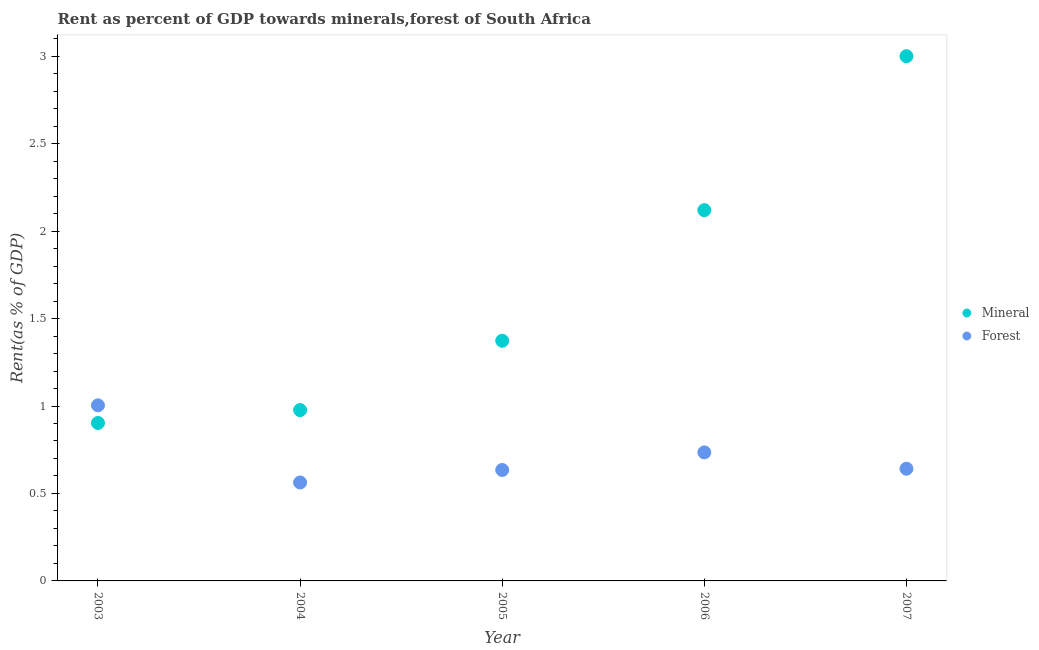What is the forest rent in 2005?
Provide a succinct answer. 0.63. Across all years, what is the maximum mineral rent?
Keep it short and to the point. 3. Across all years, what is the minimum forest rent?
Ensure brevity in your answer.  0.56. What is the total mineral rent in the graph?
Your response must be concise. 8.37. What is the difference between the mineral rent in 2004 and that in 2005?
Offer a terse response. -0.4. What is the difference between the mineral rent in 2003 and the forest rent in 2007?
Give a very brief answer. 0.26. What is the average forest rent per year?
Ensure brevity in your answer.  0.72. In the year 2003, what is the difference between the mineral rent and forest rent?
Provide a succinct answer. -0.1. What is the ratio of the mineral rent in 2005 to that in 2006?
Your answer should be very brief. 0.65. Is the forest rent in 2004 less than that in 2006?
Keep it short and to the point. Yes. What is the difference between the highest and the second highest forest rent?
Your answer should be very brief. 0.27. What is the difference between the highest and the lowest mineral rent?
Your answer should be very brief. 2.1. Is the sum of the forest rent in 2003 and 2007 greater than the maximum mineral rent across all years?
Provide a succinct answer. No. How many dotlines are there?
Give a very brief answer. 2. What is the difference between two consecutive major ticks on the Y-axis?
Keep it short and to the point. 0.5. Does the graph contain grids?
Your response must be concise. No. Where does the legend appear in the graph?
Make the answer very short. Center right. How are the legend labels stacked?
Provide a short and direct response. Vertical. What is the title of the graph?
Make the answer very short. Rent as percent of GDP towards minerals,forest of South Africa. Does "From human activities" appear as one of the legend labels in the graph?
Your answer should be compact. No. What is the label or title of the Y-axis?
Your answer should be very brief. Rent(as % of GDP). What is the Rent(as % of GDP) in Mineral in 2003?
Give a very brief answer. 0.9. What is the Rent(as % of GDP) in Forest in 2003?
Your answer should be very brief. 1. What is the Rent(as % of GDP) of Mineral in 2004?
Make the answer very short. 0.98. What is the Rent(as % of GDP) in Forest in 2004?
Your response must be concise. 0.56. What is the Rent(as % of GDP) in Mineral in 2005?
Provide a succinct answer. 1.37. What is the Rent(as % of GDP) of Forest in 2005?
Provide a succinct answer. 0.63. What is the Rent(as % of GDP) of Mineral in 2006?
Provide a succinct answer. 2.12. What is the Rent(as % of GDP) of Forest in 2006?
Make the answer very short. 0.73. What is the Rent(as % of GDP) in Mineral in 2007?
Provide a short and direct response. 3. What is the Rent(as % of GDP) in Forest in 2007?
Make the answer very short. 0.64. Across all years, what is the maximum Rent(as % of GDP) of Mineral?
Offer a terse response. 3. Across all years, what is the maximum Rent(as % of GDP) in Forest?
Offer a very short reply. 1. Across all years, what is the minimum Rent(as % of GDP) in Mineral?
Your answer should be very brief. 0.9. Across all years, what is the minimum Rent(as % of GDP) of Forest?
Your answer should be compact. 0.56. What is the total Rent(as % of GDP) in Mineral in the graph?
Ensure brevity in your answer.  8.37. What is the total Rent(as % of GDP) in Forest in the graph?
Give a very brief answer. 3.58. What is the difference between the Rent(as % of GDP) in Mineral in 2003 and that in 2004?
Offer a terse response. -0.07. What is the difference between the Rent(as % of GDP) in Forest in 2003 and that in 2004?
Provide a succinct answer. 0.44. What is the difference between the Rent(as % of GDP) of Mineral in 2003 and that in 2005?
Offer a very short reply. -0.47. What is the difference between the Rent(as % of GDP) in Forest in 2003 and that in 2005?
Make the answer very short. 0.37. What is the difference between the Rent(as % of GDP) in Mineral in 2003 and that in 2006?
Make the answer very short. -1.22. What is the difference between the Rent(as % of GDP) in Forest in 2003 and that in 2006?
Provide a short and direct response. 0.27. What is the difference between the Rent(as % of GDP) of Mineral in 2003 and that in 2007?
Provide a short and direct response. -2.1. What is the difference between the Rent(as % of GDP) in Forest in 2003 and that in 2007?
Your answer should be compact. 0.36. What is the difference between the Rent(as % of GDP) of Mineral in 2004 and that in 2005?
Ensure brevity in your answer.  -0.4. What is the difference between the Rent(as % of GDP) in Forest in 2004 and that in 2005?
Offer a terse response. -0.07. What is the difference between the Rent(as % of GDP) of Mineral in 2004 and that in 2006?
Your answer should be compact. -1.14. What is the difference between the Rent(as % of GDP) in Forest in 2004 and that in 2006?
Ensure brevity in your answer.  -0.17. What is the difference between the Rent(as % of GDP) of Mineral in 2004 and that in 2007?
Make the answer very short. -2.02. What is the difference between the Rent(as % of GDP) in Forest in 2004 and that in 2007?
Give a very brief answer. -0.08. What is the difference between the Rent(as % of GDP) of Mineral in 2005 and that in 2006?
Ensure brevity in your answer.  -0.75. What is the difference between the Rent(as % of GDP) of Forest in 2005 and that in 2006?
Give a very brief answer. -0.1. What is the difference between the Rent(as % of GDP) in Mineral in 2005 and that in 2007?
Provide a succinct answer. -1.63. What is the difference between the Rent(as % of GDP) of Forest in 2005 and that in 2007?
Your response must be concise. -0.01. What is the difference between the Rent(as % of GDP) of Mineral in 2006 and that in 2007?
Offer a very short reply. -0.88. What is the difference between the Rent(as % of GDP) in Forest in 2006 and that in 2007?
Make the answer very short. 0.09. What is the difference between the Rent(as % of GDP) in Mineral in 2003 and the Rent(as % of GDP) in Forest in 2004?
Provide a succinct answer. 0.34. What is the difference between the Rent(as % of GDP) of Mineral in 2003 and the Rent(as % of GDP) of Forest in 2005?
Offer a terse response. 0.27. What is the difference between the Rent(as % of GDP) of Mineral in 2003 and the Rent(as % of GDP) of Forest in 2006?
Offer a very short reply. 0.17. What is the difference between the Rent(as % of GDP) of Mineral in 2003 and the Rent(as % of GDP) of Forest in 2007?
Offer a terse response. 0.26. What is the difference between the Rent(as % of GDP) of Mineral in 2004 and the Rent(as % of GDP) of Forest in 2005?
Ensure brevity in your answer.  0.34. What is the difference between the Rent(as % of GDP) of Mineral in 2004 and the Rent(as % of GDP) of Forest in 2006?
Keep it short and to the point. 0.24. What is the difference between the Rent(as % of GDP) of Mineral in 2004 and the Rent(as % of GDP) of Forest in 2007?
Make the answer very short. 0.34. What is the difference between the Rent(as % of GDP) of Mineral in 2005 and the Rent(as % of GDP) of Forest in 2006?
Provide a succinct answer. 0.64. What is the difference between the Rent(as % of GDP) in Mineral in 2005 and the Rent(as % of GDP) in Forest in 2007?
Give a very brief answer. 0.73. What is the difference between the Rent(as % of GDP) of Mineral in 2006 and the Rent(as % of GDP) of Forest in 2007?
Your answer should be compact. 1.48. What is the average Rent(as % of GDP) in Mineral per year?
Your answer should be very brief. 1.67. What is the average Rent(as % of GDP) of Forest per year?
Ensure brevity in your answer.  0.72. In the year 2003, what is the difference between the Rent(as % of GDP) in Mineral and Rent(as % of GDP) in Forest?
Provide a succinct answer. -0.1. In the year 2004, what is the difference between the Rent(as % of GDP) in Mineral and Rent(as % of GDP) in Forest?
Your response must be concise. 0.41. In the year 2005, what is the difference between the Rent(as % of GDP) of Mineral and Rent(as % of GDP) of Forest?
Your answer should be very brief. 0.74. In the year 2006, what is the difference between the Rent(as % of GDP) in Mineral and Rent(as % of GDP) in Forest?
Provide a short and direct response. 1.38. In the year 2007, what is the difference between the Rent(as % of GDP) in Mineral and Rent(as % of GDP) in Forest?
Your answer should be compact. 2.36. What is the ratio of the Rent(as % of GDP) in Mineral in 2003 to that in 2004?
Provide a succinct answer. 0.92. What is the ratio of the Rent(as % of GDP) in Forest in 2003 to that in 2004?
Provide a succinct answer. 1.78. What is the ratio of the Rent(as % of GDP) of Mineral in 2003 to that in 2005?
Keep it short and to the point. 0.66. What is the ratio of the Rent(as % of GDP) in Forest in 2003 to that in 2005?
Ensure brevity in your answer.  1.58. What is the ratio of the Rent(as % of GDP) of Mineral in 2003 to that in 2006?
Your answer should be compact. 0.43. What is the ratio of the Rent(as % of GDP) of Forest in 2003 to that in 2006?
Provide a succinct answer. 1.37. What is the ratio of the Rent(as % of GDP) of Mineral in 2003 to that in 2007?
Provide a short and direct response. 0.3. What is the ratio of the Rent(as % of GDP) of Forest in 2003 to that in 2007?
Ensure brevity in your answer.  1.56. What is the ratio of the Rent(as % of GDP) of Mineral in 2004 to that in 2005?
Your response must be concise. 0.71. What is the ratio of the Rent(as % of GDP) in Forest in 2004 to that in 2005?
Provide a succinct answer. 0.89. What is the ratio of the Rent(as % of GDP) in Mineral in 2004 to that in 2006?
Make the answer very short. 0.46. What is the ratio of the Rent(as % of GDP) in Forest in 2004 to that in 2006?
Provide a succinct answer. 0.77. What is the ratio of the Rent(as % of GDP) in Mineral in 2004 to that in 2007?
Keep it short and to the point. 0.33. What is the ratio of the Rent(as % of GDP) of Forest in 2004 to that in 2007?
Offer a terse response. 0.88. What is the ratio of the Rent(as % of GDP) of Mineral in 2005 to that in 2006?
Offer a terse response. 0.65. What is the ratio of the Rent(as % of GDP) in Forest in 2005 to that in 2006?
Keep it short and to the point. 0.86. What is the ratio of the Rent(as % of GDP) in Mineral in 2005 to that in 2007?
Offer a very short reply. 0.46. What is the ratio of the Rent(as % of GDP) of Mineral in 2006 to that in 2007?
Make the answer very short. 0.71. What is the ratio of the Rent(as % of GDP) in Forest in 2006 to that in 2007?
Ensure brevity in your answer.  1.15. What is the difference between the highest and the second highest Rent(as % of GDP) in Mineral?
Your response must be concise. 0.88. What is the difference between the highest and the second highest Rent(as % of GDP) in Forest?
Offer a very short reply. 0.27. What is the difference between the highest and the lowest Rent(as % of GDP) of Mineral?
Ensure brevity in your answer.  2.1. What is the difference between the highest and the lowest Rent(as % of GDP) in Forest?
Provide a short and direct response. 0.44. 